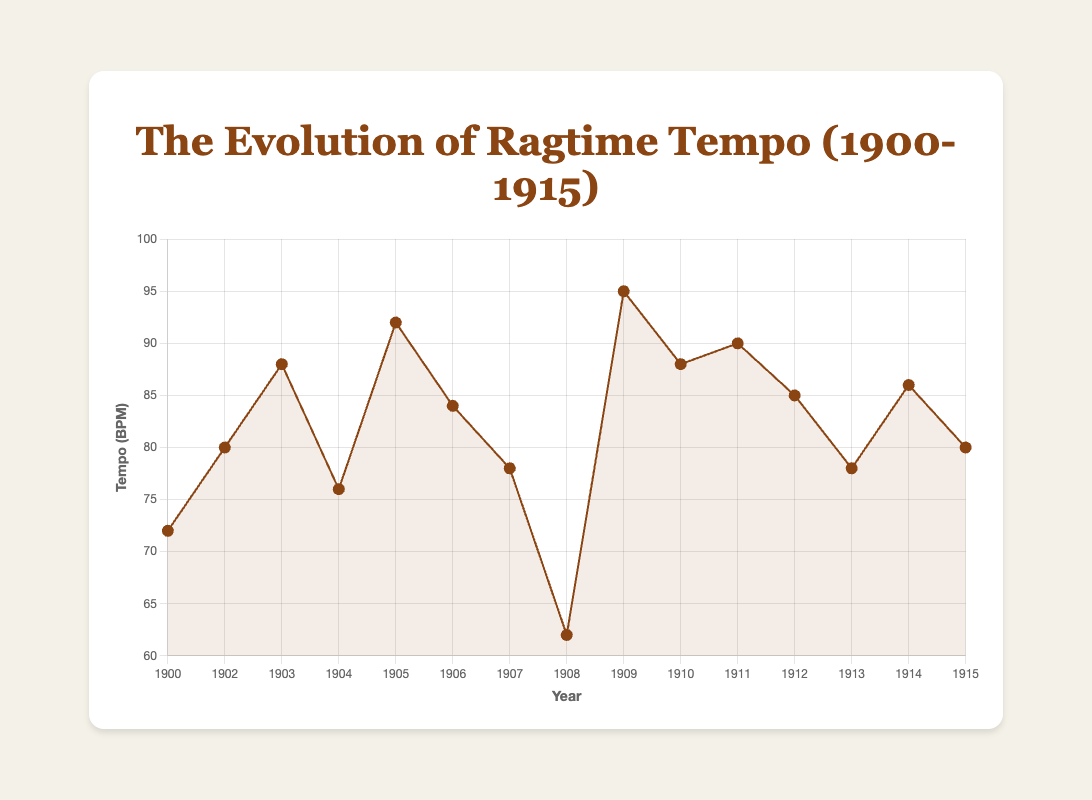What's the average tempo of Scott Joplin's pieces over the years? Scott Joplin composed 9 pieces during 1900-1915. The tempos are: 72, 80, 88, 76, 84, 78, 62, 78, and 80 BPM. Summing them gives 698 BPM, and dividing by 9 gives about 77.56 BPM.
Answer: 77.56 BPM Which year featured the piece with the highest tempo? The tempo in 1909 for "Creole Belles" is 95 BPM, which is the highest tempo among all pieces in the data set.
Answer: 1909 How many pieces have a tempo higher than 85 BPM? The tempos higher than 85 BPM are: 88 BPM ("The Cascades" in 1903), 92 BPM ("Frog Legs Rag" in 1905), 95 BPM ("Creole Belles" in 1909), 90 BPM ("Grace and Beauty" in 1911), 85 BPM ("Ragtime Oriole" in 1912), and 86 BPM ("St. Louis Rag" in 1914). There are 6 pieces in total.
Answer: 6 What's the median tempo of the pieces from 1900 to 1915? Arranging the unique tempos in ascending order: 62, 72, 76, 78, 80, 84, 85, 86, 88, 90, 92, 95, the median value (middle value of the ordered list) is 84 BPM.
Answer: 84 BPM What's the change in tempo from "Maple Leaf Rag" to "The Entertainer"? The tempo of "Maple Leaf Rag" in 1900 is 72 BPM, and for "The Entertainer" in 1902 is 80 BPM. The change in tempo is 80 - 72 = 8 BPM.
Answer: 8 BPM In which year does the tempo of the pieces drop the most from the previous year? The drop in tempo from 1907 to 1908 is from 78 BPM to 62 BPM, a difference of 16 BPM, which is the largest drop between any two consecutive years.
Answer: 1908 Which piece composed by Scott Joplin has the lowest tempo? "Sunflower Slow Drag" in 1908 has the lowest tempo of 62 BPM among all pieces composed by Scott Joplin.
Answer: Sunflower Slow Drag Is there a general trend of increasing or decreasing tempo over the years from 1900 to 1915? Analyzing the tempos over the years, despite some fluctuations, there is no clear, consistent increasing or decreasing trend. The tempos vary up and down through the years.
Answer: No clear trend Which pieces in the data have an equal tempo and what is that tempo? The pieces "Pine Apple Rag" (1907) and "Peacherine Rag" (1913) both have a tempo of 78 BPM. Additionally, "The Entertainer" (1902) and "Euphonic Sounds" (1915) both have a tempo of 80 BPM. These pairs of pieces share equal tempos.
Answer: Pine Apple Rag / Peacherine Rag (78 BPM), The Entertainer / Euphonic Sounds (80 BPM) What is the difference in tempo between the fastest piece and the slowest piece? The fastest piece is "Creole Belles" in 1909 with 95 BPM, and the slowest piece is "Sunflower Slow Drag" in 1908 with 62 BPM. The difference is 95 - 62 = 33 BPM.
Answer: 33 BPM 